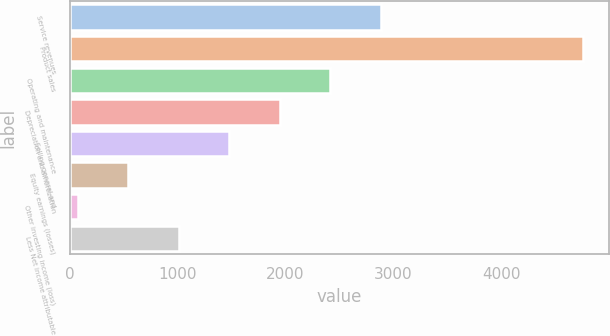<chart> <loc_0><loc_0><loc_500><loc_500><bar_chart><fcel>Service revenues<fcel>Product sales<fcel>Operating and maintenance<fcel>Depreciation and amortization<fcel>Selling general and<fcel>Equity earnings (losses)<fcel>Other investing income (loss)<fcel>Less Net income attributable<nl><fcel>2885<fcel>4757<fcel>2417<fcel>1949<fcel>1481<fcel>545<fcel>77<fcel>1013<nl></chart> 